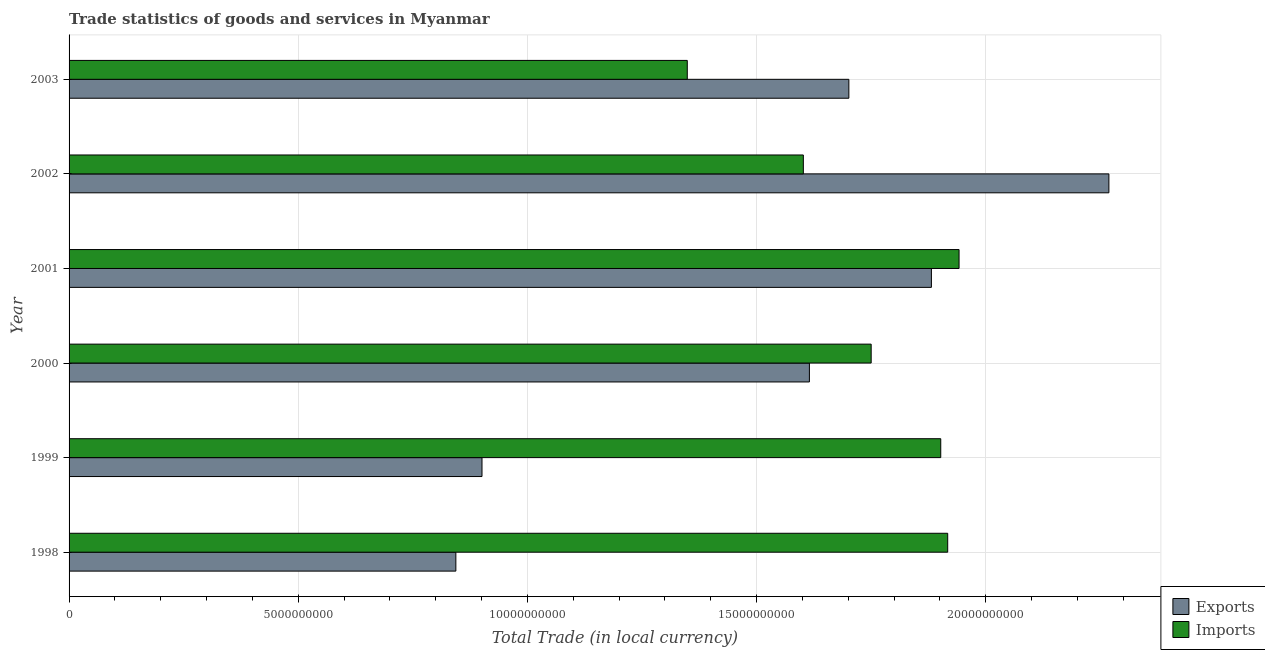How many groups of bars are there?
Your answer should be compact. 6. Are the number of bars on each tick of the Y-axis equal?
Your response must be concise. Yes. How many bars are there on the 1st tick from the bottom?
Your answer should be very brief. 2. What is the imports of goods and services in 2000?
Your answer should be compact. 1.75e+1. Across all years, what is the maximum export of goods and services?
Offer a very short reply. 2.27e+1. Across all years, what is the minimum export of goods and services?
Make the answer very short. 8.44e+09. What is the total export of goods and services in the graph?
Your answer should be compact. 9.21e+1. What is the difference between the imports of goods and services in 1999 and that in 2002?
Provide a short and direct response. 3.00e+09. What is the difference between the export of goods and services in 1998 and the imports of goods and services in 2001?
Offer a very short reply. -1.10e+1. What is the average export of goods and services per year?
Make the answer very short. 1.54e+1. In the year 1999, what is the difference between the imports of goods and services and export of goods and services?
Offer a very short reply. 1.00e+1. In how many years, is the imports of goods and services greater than 22000000000 LCU?
Offer a terse response. 0. What is the ratio of the imports of goods and services in 1998 to that in 2002?
Your answer should be compact. 1.2. What is the difference between the highest and the second highest imports of goods and services?
Provide a succinct answer. 2.48e+08. What is the difference between the highest and the lowest imports of goods and services?
Ensure brevity in your answer.  5.93e+09. Is the sum of the export of goods and services in 2000 and 2001 greater than the maximum imports of goods and services across all years?
Provide a succinct answer. Yes. What does the 2nd bar from the top in 1998 represents?
Make the answer very short. Exports. What does the 1st bar from the bottom in 2003 represents?
Give a very brief answer. Exports. Are all the bars in the graph horizontal?
Offer a very short reply. Yes. What is the difference between two consecutive major ticks on the X-axis?
Offer a very short reply. 5.00e+09. Are the values on the major ticks of X-axis written in scientific E-notation?
Ensure brevity in your answer.  No. Does the graph contain grids?
Give a very brief answer. Yes. What is the title of the graph?
Your response must be concise. Trade statistics of goods and services in Myanmar. What is the label or title of the X-axis?
Provide a succinct answer. Total Trade (in local currency). What is the Total Trade (in local currency) in Exports in 1998?
Make the answer very short. 8.44e+09. What is the Total Trade (in local currency) of Imports in 1998?
Provide a short and direct response. 1.92e+1. What is the Total Trade (in local currency) of Exports in 1999?
Provide a short and direct response. 9.01e+09. What is the Total Trade (in local currency) of Imports in 1999?
Give a very brief answer. 1.90e+1. What is the Total Trade (in local currency) of Exports in 2000?
Make the answer very short. 1.62e+1. What is the Total Trade (in local currency) of Imports in 2000?
Your answer should be very brief. 1.75e+1. What is the Total Trade (in local currency) of Exports in 2001?
Your response must be concise. 1.88e+1. What is the Total Trade (in local currency) of Imports in 2001?
Provide a short and direct response. 1.94e+1. What is the Total Trade (in local currency) in Exports in 2002?
Keep it short and to the point. 2.27e+1. What is the Total Trade (in local currency) of Imports in 2002?
Ensure brevity in your answer.  1.60e+1. What is the Total Trade (in local currency) in Exports in 2003?
Offer a terse response. 1.70e+1. What is the Total Trade (in local currency) in Imports in 2003?
Offer a very short reply. 1.35e+1. Across all years, what is the maximum Total Trade (in local currency) of Exports?
Provide a succinct answer. 2.27e+1. Across all years, what is the maximum Total Trade (in local currency) in Imports?
Offer a very short reply. 1.94e+1. Across all years, what is the minimum Total Trade (in local currency) in Exports?
Your answer should be very brief. 8.44e+09. Across all years, what is the minimum Total Trade (in local currency) in Imports?
Your answer should be compact. 1.35e+1. What is the total Total Trade (in local currency) in Exports in the graph?
Provide a short and direct response. 9.21e+1. What is the total Total Trade (in local currency) in Imports in the graph?
Your answer should be very brief. 1.05e+11. What is the difference between the Total Trade (in local currency) of Exports in 1998 and that in 1999?
Make the answer very short. -5.70e+08. What is the difference between the Total Trade (in local currency) of Imports in 1998 and that in 1999?
Provide a short and direct response. 1.52e+08. What is the difference between the Total Trade (in local currency) in Exports in 1998 and that in 2000?
Provide a succinct answer. -7.71e+09. What is the difference between the Total Trade (in local currency) in Imports in 1998 and that in 2000?
Keep it short and to the point. 1.67e+09. What is the difference between the Total Trade (in local currency) of Exports in 1998 and that in 2001?
Keep it short and to the point. -1.04e+1. What is the difference between the Total Trade (in local currency) in Imports in 1998 and that in 2001?
Your answer should be very brief. -2.48e+08. What is the difference between the Total Trade (in local currency) of Exports in 1998 and that in 2002?
Offer a very short reply. -1.42e+1. What is the difference between the Total Trade (in local currency) in Imports in 1998 and that in 2002?
Your answer should be compact. 3.15e+09. What is the difference between the Total Trade (in local currency) in Exports in 1998 and that in 2003?
Keep it short and to the point. -8.57e+09. What is the difference between the Total Trade (in local currency) of Imports in 1998 and that in 2003?
Provide a succinct answer. 5.68e+09. What is the difference between the Total Trade (in local currency) of Exports in 1999 and that in 2000?
Offer a very short reply. -7.14e+09. What is the difference between the Total Trade (in local currency) of Imports in 1999 and that in 2000?
Ensure brevity in your answer.  1.52e+09. What is the difference between the Total Trade (in local currency) of Exports in 1999 and that in 2001?
Offer a very short reply. -9.80e+09. What is the difference between the Total Trade (in local currency) in Imports in 1999 and that in 2001?
Your answer should be very brief. -3.99e+08. What is the difference between the Total Trade (in local currency) of Exports in 1999 and that in 2002?
Provide a succinct answer. -1.37e+1. What is the difference between the Total Trade (in local currency) of Imports in 1999 and that in 2002?
Provide a succinct answer. 3.00e+09. What is the difference between the Total Trade (in local currency) in Exports in 1999 and that in 2003?
Keep it short and to the point. -8.00e+09. What is the difference between the Total Trade (in local currency) in Imports in 1999 and that in 2003?
Provide a succinct answer. 5.53e+09. What is the difference between the Total Trade (in local currency) in Exports in 2000 and that in 2001?
Your response must be concise. -2.66e+09. What is the difference between the Total Trade (in local currency) in Imports in 2000 and that in 2001?
Ensure brevity in your answer.  -1.92e+09. What is the difference between the Total Trade (in local currency) of Exports in 2000 and that in 2002?
Make the answer very short. -6.53e+09. What is the difference between the Total Trade (in local currency) in Imports in 2000 and that in 2002?
Ensure brevity in your answer.  1.48e+09. What is the difference between the Total Trade (in local currency) in Exports in 2000 and that in 2003?
Give a very brief answer. -8.61e+08. What is the difference between the Total Trade (in local currency) of Imports in 2000 and that in 2003?
Your answer should be very brief. 4.01e+09. What is the difference between the Total Trade (in local currency) of Exports in 2001 and that in 2002?
Make the answer very short. -3.87e+09. What is the difference between the Total Trade (in local currency) in Imports in 2001 and that in 2002?
Your answer should be compact. 3.40e+09. What is the difference between the Total Trade (in local currency) in Exports in 2001 and that in 2003?
Your response must be concise. 1.80e+09. What is the difference between the Total Trade (in local currency) of Imports in 2001 and that in 2003?
Offer a very short reply. 5.93e+09. What is the difference between the Total Trade (in local currency) in Exports in 2002 and that in 2003?
Your answer should be compact. 5.67e+09. What is the difference between the Total Trade (in local currency) in Imports in 2002 and that in 2003?
Provide a short and direct response. 2.53e+09. What is the difference between the Total Trade (in local currency) in Exports in 1998 and the Total Trade (in local currency) in Imports in 1999?
Offer a very short reply. -1.06e+1. What is the difference between the Total Trade (in local currency) in Exports in 1998 and the Total Trade (in local currency) in Imports in 2000?
Offer a very short reply. -9.06e+09. What is the difference between the Total Trade (in local currency) of Exports in 1998 and the Total Trade (in local currency) of Imports in 2001?
Ensure brevity in your answer.  -1.10e+1. What is the difference between the Total Trade (in local currency) in Exports in 1998 and the Total Trade (in local currency) in Imports in 2002?
Make the answer very short. -7.58e+09. What is the difference between the Total Trade (in local currency) in Exports in 1998 and the Total Trade (in local currency) in Imports in 2003?
Your answer should be very brief. -5.05e+09. What is the difference between the Total Trade (in local currency) of Exports in 1999 and the Total Trade (in local currency) of Imports in 2000?
Provide a short and direct response. -8.49e+09. What is the difference between the Total Trade (in local currency) in Exports in 1999 and the Total Trade (in local currency) in Imports in 2001?
Your answer should be very brief. -1.04e+1. What is the difference between the Total Trade (in local currency) of Exports in 1999 and the Total Trade (in local currency) of Imports in 2002?
Offer a very short reply. -7.01e+09. What is the difference between the Total Trade (in local currency) in Exports in 1999 and the Total Trade (in local currency) in Imports in 2003?
Your answer should be compact. -4.48e+09. What is the difference between the Total Trade (in local currency) in Exports in 2000 and the Total Trade (in local currency) in Imports in 2001?
Your response must be concise. -3.27e+09. What is the difference between the Total Trade (in local currency) in Exports in 2000 and the Total Trade (in local currency) in Imports in 2002?
Your answer should be very brief. 1.32e+08. What is the difference between the Total Trade (in local currency) of Exports in 2000 and the Total Trade (in local currency) of Imports in 2003?
Your answer should be compact. 2.66e+09. What is the difference between the Total Trade (in local currency) in Exports in 2001 and the Total Trade (in local currency) in Imports in 2002?
Make the answer very short. 2.79e+09. What is the difference between the Total Trade (in local currency) of Exports in 2001 and the Total Trade (in local currency) of Imports in 2003?
Ensure brevity in your answer.  5.33e+09. What is the difference between the Total Trade (in local currency) in Exports in 2002 and the Total Trade (in local currency) in Imports in 2003?
Your response must be concise. 9.20e+09. What is the average Total Trade (in local currency) in Exports per year?
Your answer should be compact. 1.54e+1. What is the average Total Trade (in local currency) of Imports per year?
Ensure brevity in your answer.  1.74e+1. In the year 1998, what is the difference between the Total Trade (in local currency) of Exports and Total Trade (in local currency) of Imports?
Keep it short and to the point. -1.07e+1. In the year 1999, what is the difference between the Total Trade (in local currency) of Exports and Total Trade (in local currency) of Imports?
Offer a very short reply. -1.00e+1. In the year 2000, what is the difference between the Total Trade (in local currency) in Exports and Total Trade (in local currency) in Imports?
Keep it short and to the point. -1.35e+09. In the year 2001, what is the difference between the Total Trade (in local currency) in Exports and Total Trade (in local currency) in Imports?
Your response must be concise. -6.03e+08. In the year 2002, what is the difference between the Total Trade (in local currency) of Exports and Total Trade (in local currency) of Imports?
Keep it short and to the point. 6.67e+09. In the year 2003, what is the difference between the Total Trade (in local currency) in Exports and Total Trade (in local currency) in Imports?
Give a very brief answer. 3.53e+09. What is the ratio of the Total Trade (in local currency) of Exports in 1998 to that in 1999?
Make the answer very short. 0.94. What is the ratio of the Total Trade (in local currency) in Imports in 1998 to that in 1999?
Give a very brief answer. 1.01. What is the ratio of the Total Trade (in local currency) in Exports in 1998 to that in 2000?
Offer a very short reply. 0.52. What is the ratio of the Total Trade (in local currency) in Imports in 1998 to that in 2000?
Make the answer very short. 1.1. What is the ratio of the Total Trade (in local currency) of Exports in 1998 to that in 2001?
Ensure brevity in your answer.  0.45. What is the ratio of the Total Trade (in local currency) of Imports in 1998 to that in 2001?
Provide a short and direct response. 0.99. What is the ratio of the Total Trade (in local currency) of Exports in 1998 to that in 2002?
Provide a succinct answer. 0.37. What is the ratio of the Total Trade (in local currency) in Imports in 1998 to that in 2002?
Provide a succinct answer. 1.2. What is the ratio of the Total Trade (in local currency) of Exports in 1998 to that in 2003?
Offer a very short reply. 0.5. What is the ratio of the Total Trade (in local currency) in Imports in 1998 to that in 2003?
Keep it short and to the point. 1.42. What is the ratio of the Total Trade (in local currency) of Exports in 1999 to that in 2000?
Make the answer very short. 0.56. What is the ratio of the Total Trade (in local currency) in Imports in 1999 to that in 2000?
Make the answer very short. 1.09. What is the ratio of the Total Trade (in local currency) in Exports in 1999 to that in 2001?
Offer a terse response. 0.48. What is the ratio of the Total Trade (in local currency) of Imports in 1999 to that in 2001?
Give a very brief answer. 0.98. What is the ratio of the Total Trade (in local currency) in Exports in 1999 to that in 2002?
Give a very brief answer. 0.4. What is the ratio of the Total Trade (in local currency) in Imports in 1999 to that in 2002?
Your answer should be compact. 1.19. What is the ratio of the Total Trade (in local currency) of Exports in 1999 to that in 2003?
Your answer should be compact. 0.53. What is the ratio of the Total Trade (in local currency) in Imports in 1999 to that in 2003?
Make the answer very short. 1.41. What is the ratio of the Total Trade (in local currency) of Exports in 2000 to that in 2001?
Your answer should be compact. 0.86. What is the ratio of the Total Trade (in local currency) of Imports in 2000 to that in 2001?
Keep it short and to the point. 0.9. What is the ratio of the Total Trade (in local currency) of Exports in 2000 to that in 2002?
Provide a short and direct response. 0.71. What is the ratio of the Total Trade (in local currency) in Imports in 2000 to that in 2002?
Provide a short and direct response. 1.09. What is the ratio of the Total Trade (in local currency) in Exports in 2000 to that in 2003?
Your response must be concise. 0.95. What is the ratio of the Total Trade (in local currency) of Imports in 2000 to that in 2003?
Ensure brevity in your answer.  1.3. What is the ratio of the Total Trade (in local currency) of Exports in 2001 to that in 2002?
Keep it short and to the point. 0.83. What is the ratio of the Total Trade (in local currency) of Imports in 2001 to that in 2002?
Provide a succinct answer. 1.21. What is the ratio of the Total Trade (in local currency) of Exports in 2001 to that in 2003?
Your answer should be compact. 1.11. What is the ratio of the Total Trade (in local currency) in Imports in 2001 to that in 2003?
Make the answer very short. 1.44. What is the ratio of the Total Trade (in local currency) of Exports in 2002 to that in 2003?
Your answer should be compact. 1.33. What is the ratio of the Total Trade (in local currency) in Imports in 2002 to that in 2003?
Keep it short and to the point. 1.19. What is the difference between the highest and the second highest Total Trade (in local currency) of Exports?
Provide a succinct answer. 3.87e+09. What is the difference between the highest and the second highest Total Trade (in local currency) of Imports?
Your response must be concise. 2.48e+08. What is the difference between the highest and the lowest Total Trade (in local currency) of Exports?
Your answer should be compact. 1.42e+1. What is the difference between the highest and the lowest Total Trade (in local currency) of Imports?
Provide a succinct answer. 5.93e+09. 